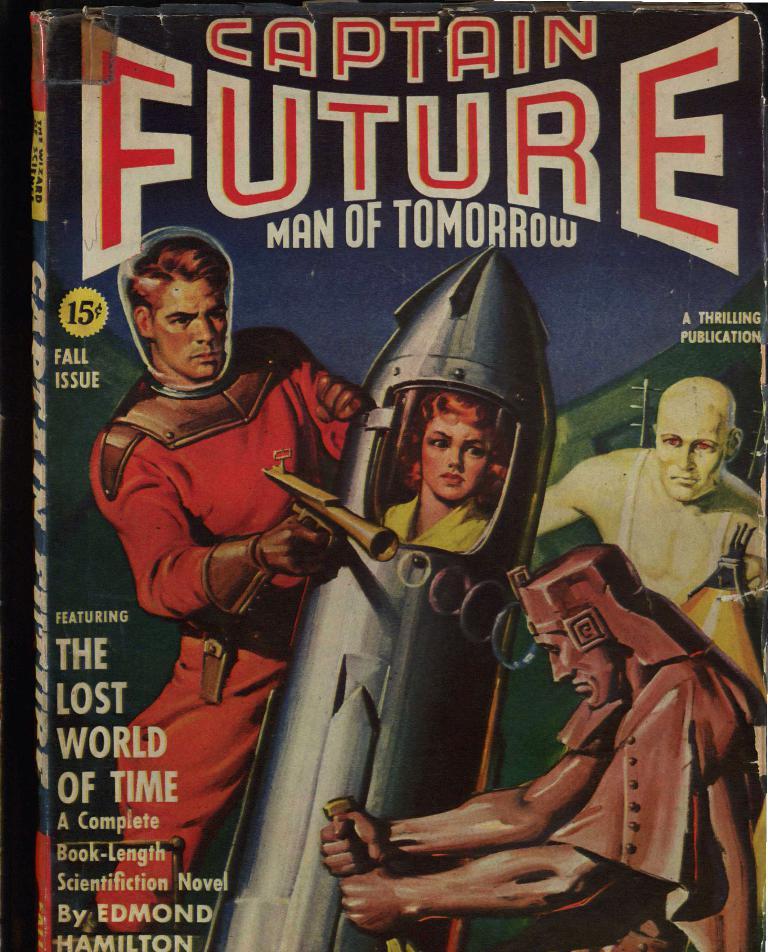How much was this novel?
Keep it short and to the point. 15 cents. What is the title here?
Give a very brief answer. Captain future man of tomorrow. 